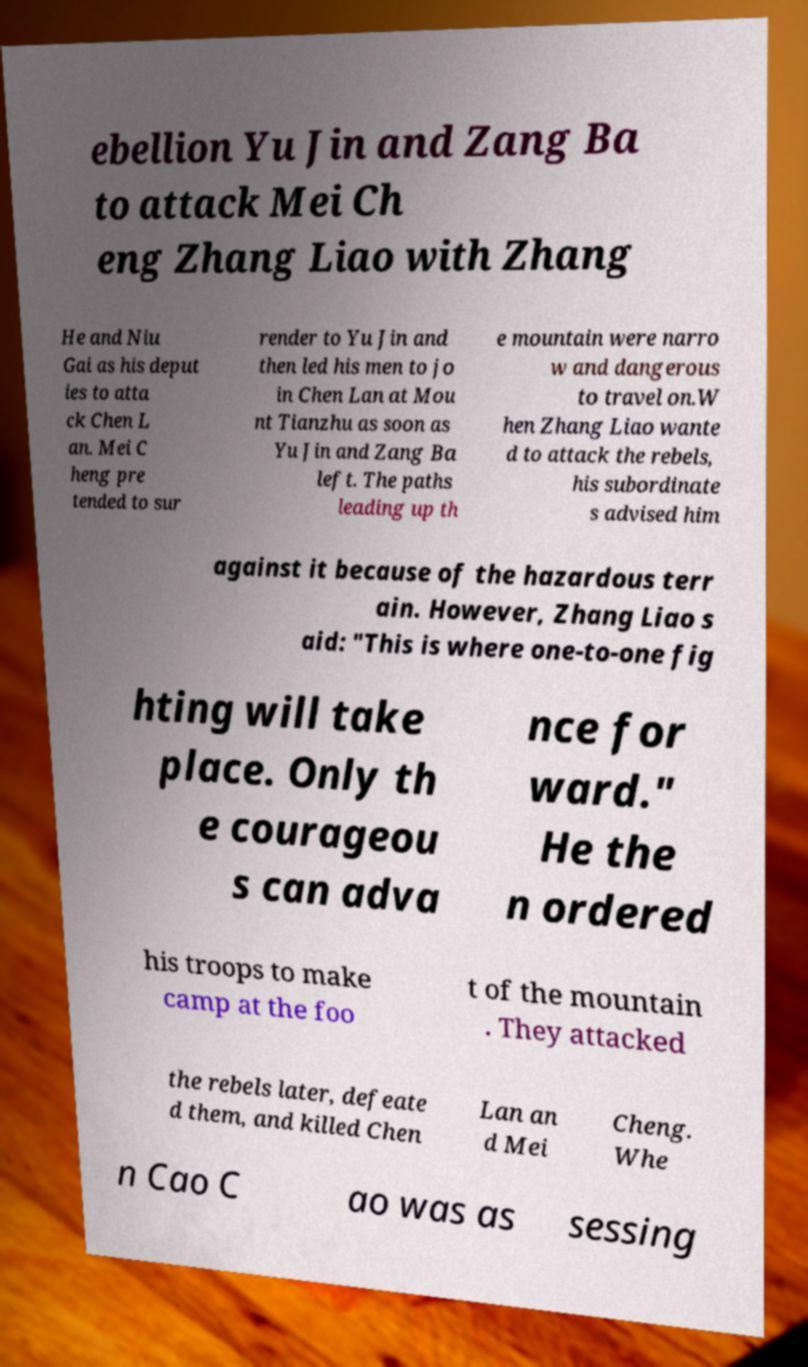There's text embedded in this image that I need extracted. Can you transcribe it verbatim? ebellion Yu Jin and Zang Ba to attack Mei Ch eng Zhang Liao with Zhang He and Niu Gai as his deput ies to atta ck Chen L an. Mei C heng pre tended to sur render to Yu Jin and then led his men to jo in Chen Lan at Mou nt Tianzhu as soon as Yu Jin and Zang Ba left. The paths leading up th e mountain were narro w and dangerous to travel on.W hen Zhang Liao wante d to attack the rebels, his subordinate s advised him against it because of the hazardous terr ain. However, Zhang Liao s aid: "This is where one-to-one fig hting will take place. Only th e courageou s can adva nce for ward." He the n ordered his troops to make camp at the foo t of the mountain . They attacked the rebels later, defeate d them, and killed Chen Lan an d Mei Cheng. Whe n Cao C ao was as sessing 